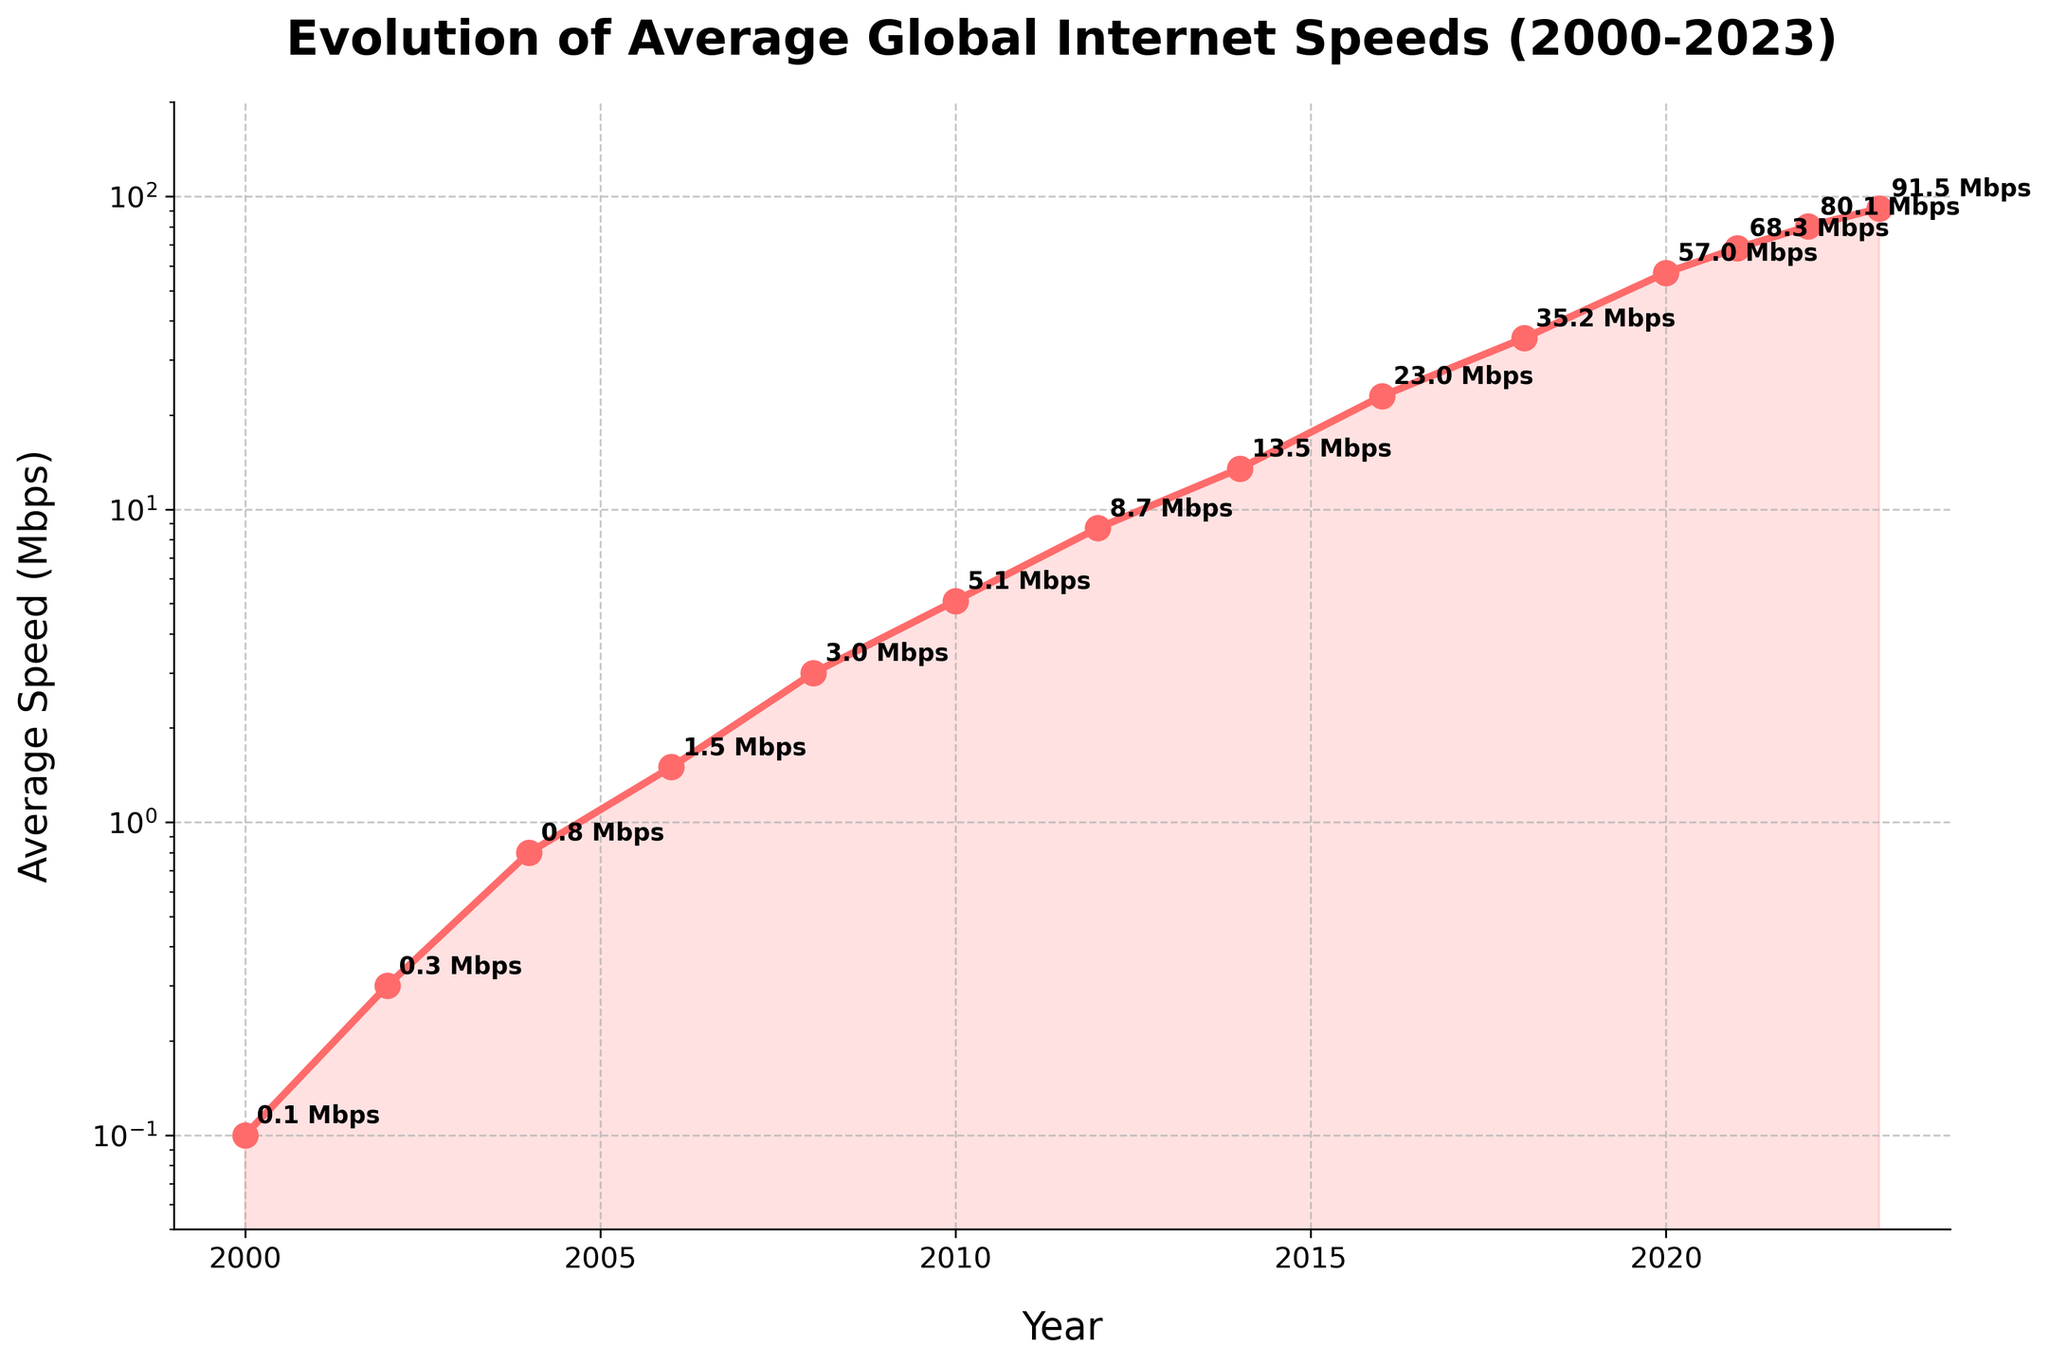What year did the average global internet speed surpass 10 Mbps? From the chart, look for the year where the speed first goes above 10 Mbps. The corresponding year to the value exceeding 10 Mbps is the answer.
Answer: 2014 Which year experienced the highest increase in average internet speed compared to its previous year? Calculate the year-on-year difference for each pair of consecutive years. The largest difference points to the year with the highest increase.
Answer: 2020 How many times did the average global internet speed double or more than double from the previous recorded year? Identify each year where the average speed is at least twice that of the previous year's speed. Count these instances.
Answer: 6 What is the general trend of the average global internet speed from 2000 to 2023? Observe the overall direction of the line in the chart from 2000 to 2023. The trend describes whether it is generally increasing, decreasing, or constant.
Answer: Increasing Between which consecutive years was the growth in internet speed the slowest? Calculate the year-on-year differences and identify the smallest positive increase. Refer to the corresponding years.
Answer: 2000-2002 Describe the visual representation used to differentiate individual data points on the line. Observe the markers, annotations, and any highlighting used on the plot points to identify individual data points.
Answer: Markers with annotations What are the general intervals of consistent, significant growth in internet speed? Identify the segments of years where the slope of the line is consistently steep, indicating significant growth. Summarize these intervals.
Answer: 2010-2020 Which year corresponds to the data point where the average internet speed reaches just below 40 Mbps? Find the point approaching but not surpassing 40 Mbps on the chart and note the corresponding year.
Answer: 2018 What is the approximate average annual growth rate in Mbps from 2000 to 2023? Calculate the total growth over the period (end speed - start speed) and divide by the number of years.
Answer: Approximately 4 Mbps per year What pattern in speed growth can be observed between 2020 and 2023? Is it consistent with earlier growth? Analyze the slope and increment pattern in later years compared to the earlier years to determine consistency.
Answer: The growth rate remains high, which is consistent 